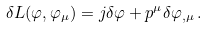<formula> <loc_0><loc_0><loc_500><loc_500>\delta L ( \varphi , \varphi _ { \mu } ) = j \delta \varphi + p ^ { \mu } \delta \varphi _ { , \mu } \, .</formula> 